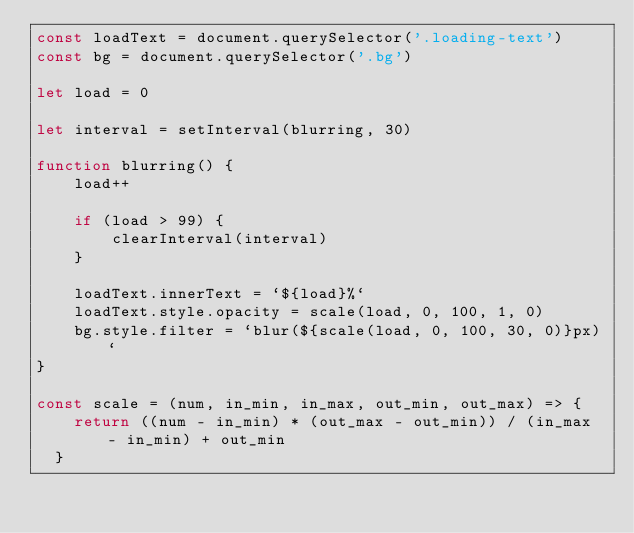<code> <loc_0><loc_0><loc_500><loc_500><_JavaScript_>const loadText = document.querySelector('.loading-text')
const bg = document.querySelector('.bg')

let load = 0

let interval = setInterval(blurring, 30)

function blurring() {
    load++

    if (load > 99) {
        clearInterval(interval)
    }

    loadText.innerText = `${load}%`
    loadText.style.opacity = scale(load, 0, 100, 1, 0)
    bg.style.filter = `blur(${scale(load, 0, 100, 30, 0)}px)`
}

const scale = (num, in_min, in_max, out_min, out_max) => {
    return ((num - in_min) * (out_max - out_min)) / (in_max - in_min) + out_min
  }
</code> 